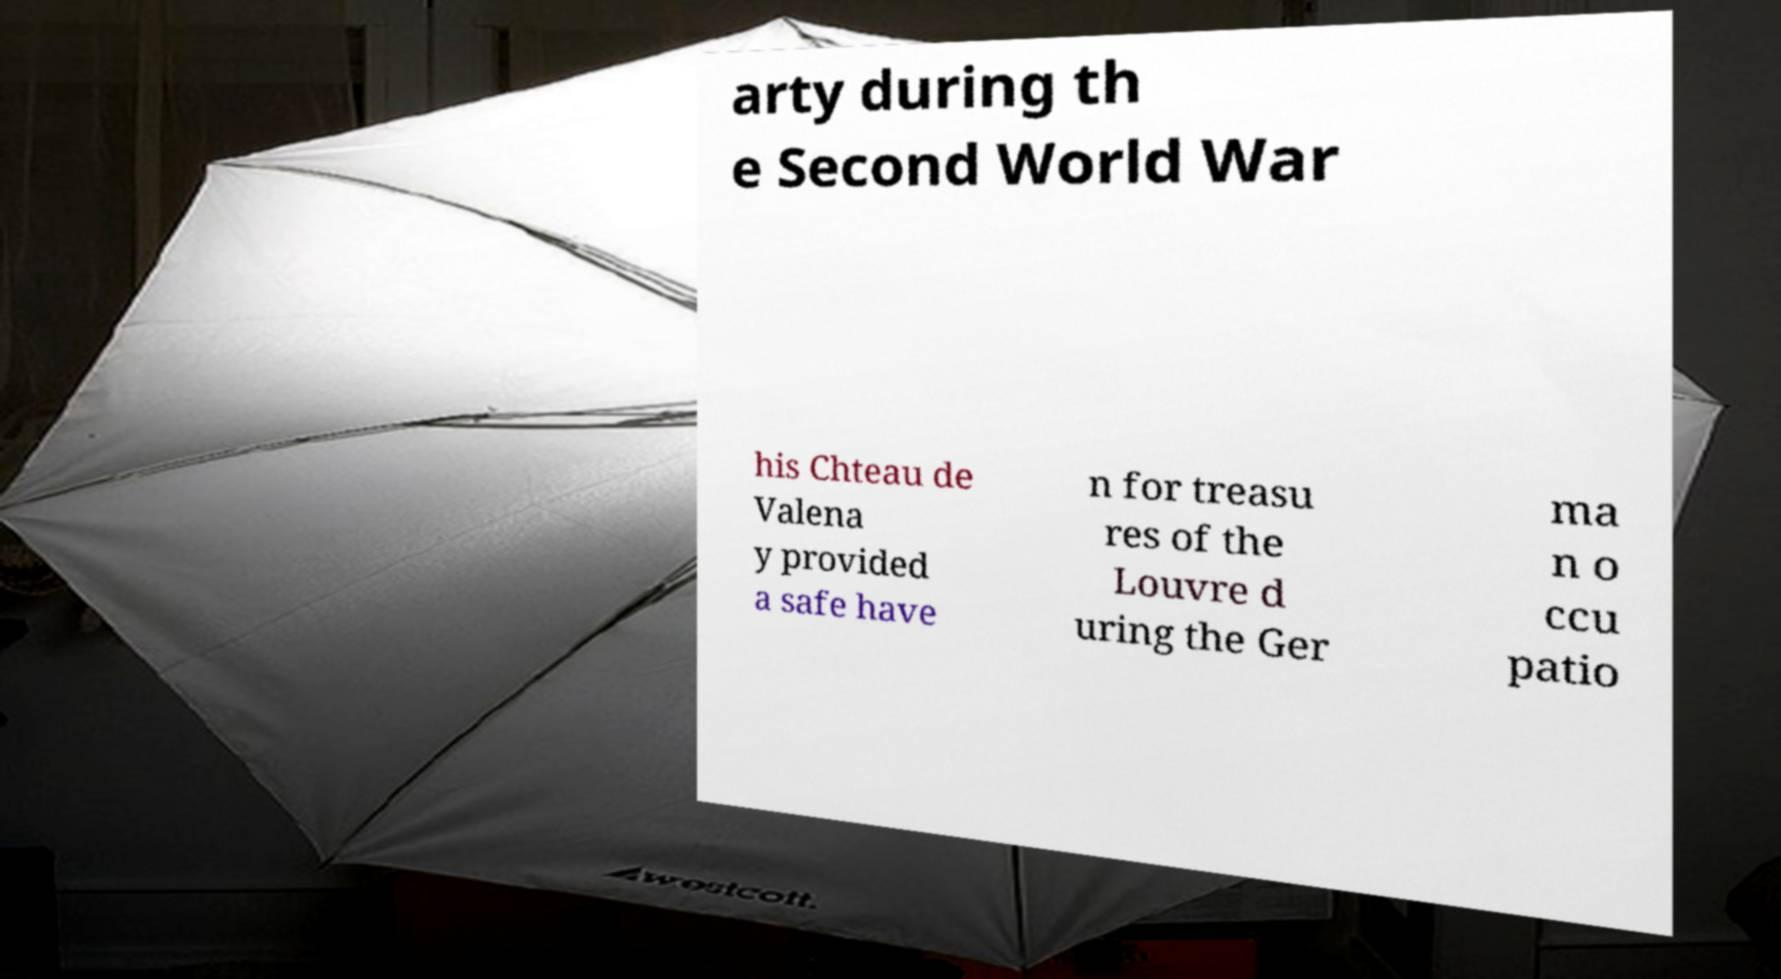What messages or text are displayed in this image? I need them in a readable, typed format. arty during th e Second World War his Chteau de Valena y provided a safe have n for treasu res of the Louvre d uring the Ger ma n o ccu patio 